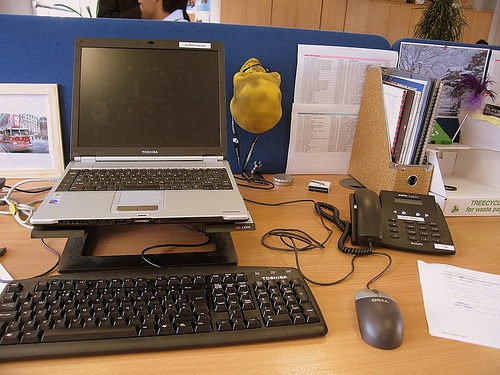Describe the objects in this image and their specific colors. I can see laptop in gray, black, and darkgray tones, keyboard in gray, black, and maroon tones, keyboard in gray, black, and maroon tones, mouse in gray, maroon, and darkgray tones, and people in gray, black, brown, and lavender tones in this image. 